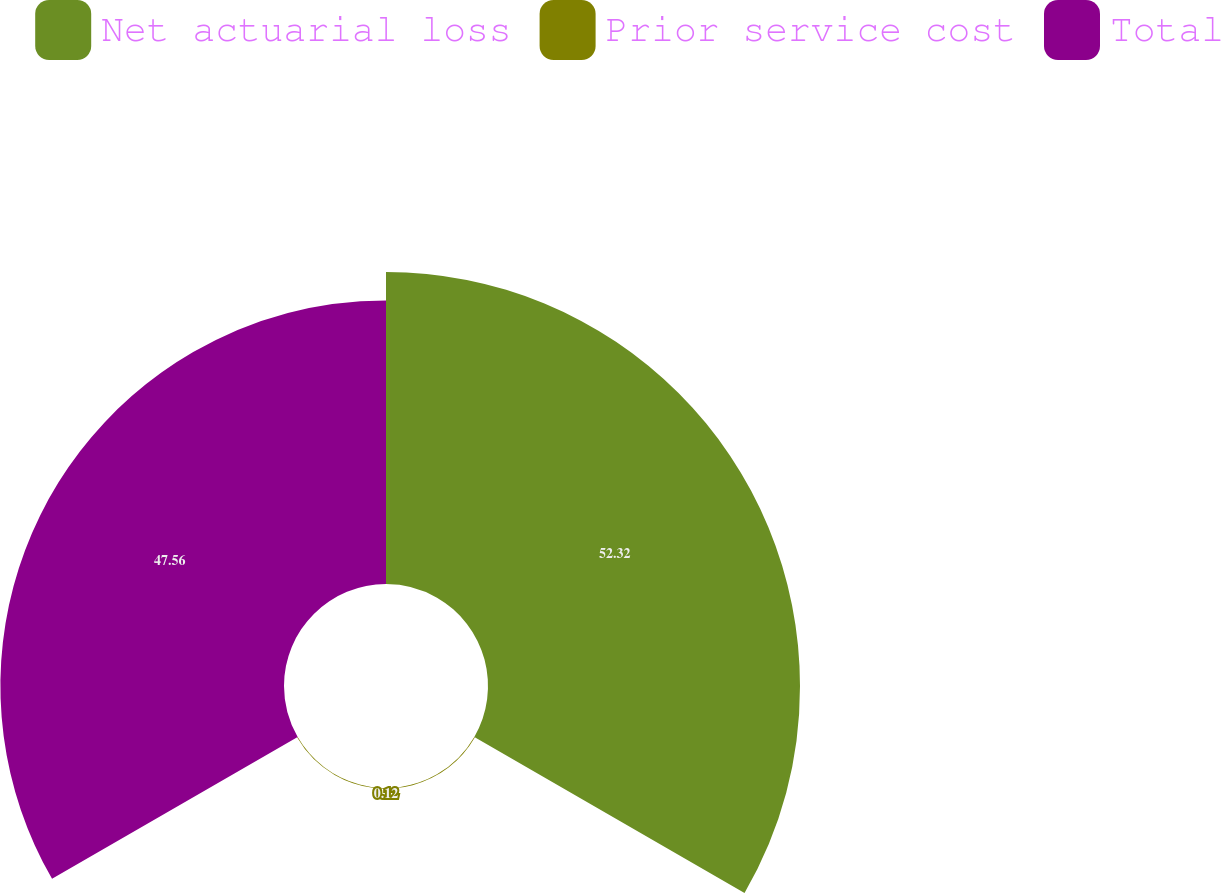<chart> <loc_0><loc_0><loc_500><loc_500><pie_chart><fcel>Net actuarial loss<fcel>Prior service cost<fcel>Total<nl><fcel>52.32%<fcel>0.12%<fcel>47.56%<nl></chart> 